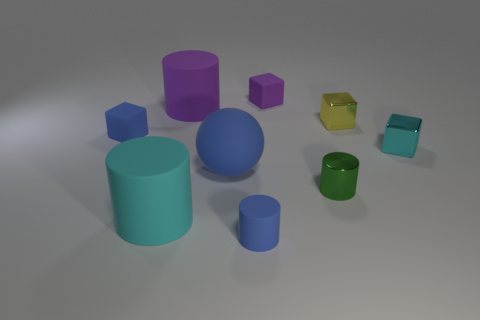What size is the cylinder that is the same material as the small yellow block?
Offer a terse response. Small. Is the number of tiny yellow objects that are on the right side of the cyan cube greater than the number of purple cylinders?
Offer a very short reply. No. How big is the blue object that is both in front of the cyan cube and behind the green object?
Offer a very short reply. Large. What material is the purple object that is the same shape as the tiny green shiny thing?
Provide a short and direct response. Rubber. There is a object in front of the cyan cylinder; is it the same size as the cyan cylinder?
Your answer should be very brief. No. The object that is both in front of the blue matte cube and right of the tiny green metallic cylinder is what color?
Keep it short and to the point. Cyan. What number of tiny rubber cubes are to the right of the rubber block in front of the yellow cube?
Give a very brief answer. 1. Do the small green thing and the tiny cyan metal thing have the same shape?
Your response must be concise. No. Is there anything else that is the same color as the large ball?
Ensure brevity in your answer.  Yes. Do the small green metal thing and the cyan object behind the big blue thing have the same shape?
Your response must be concise. No. 